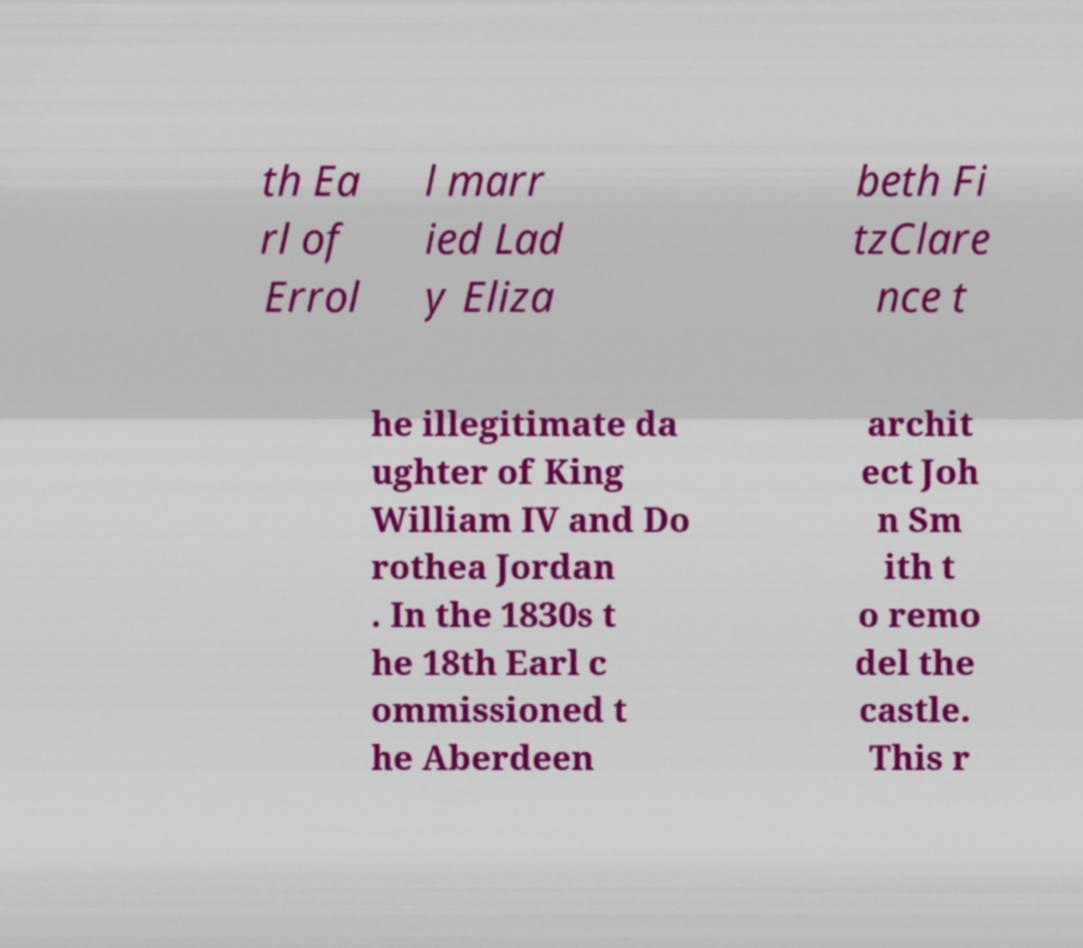Could you extract and type out the text from this image? th Ea rl of Errol l marr ied Lad y Eliza beth Fi tzClare nce t he illegitimate da ughter of King William IV and Do rothea Jordan . In the 1830s t he 18th Earl c ommissioned t he Aberdeen archit ect Joh n Sm ith t o remo del the castle. This r 